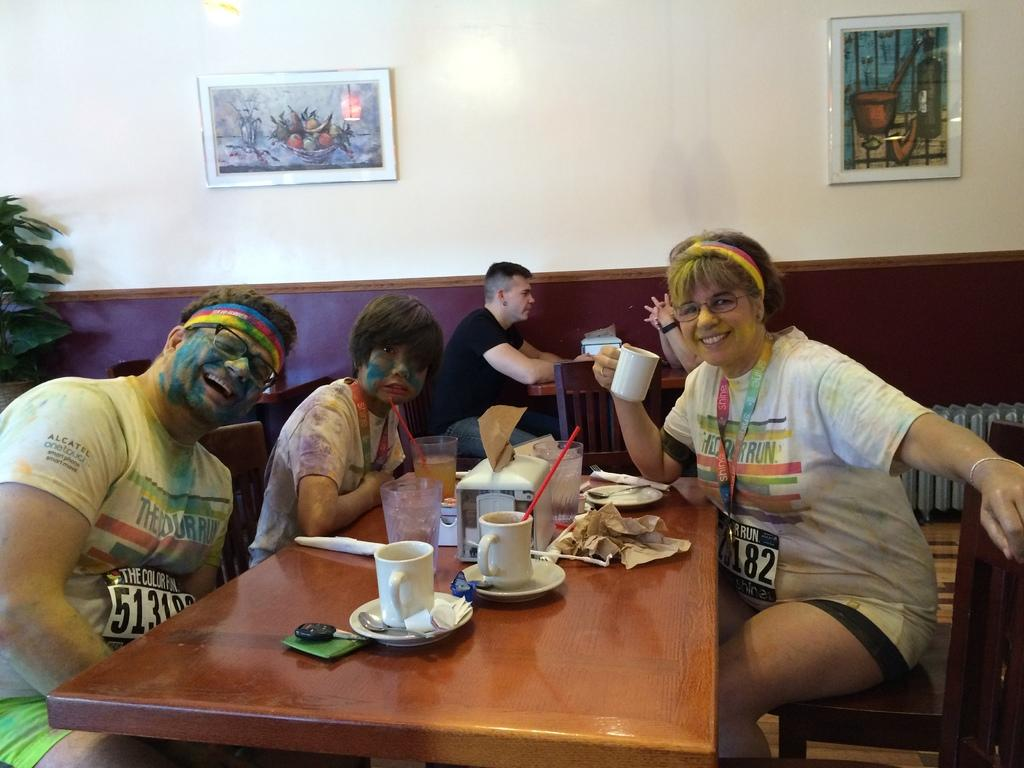How many people are sitting in the image? There are five people sitting on chairs in the image. What objects can be seen on the table? There is a cup, a saucer, a spoon, a straw, and a glass on the table. What is attached to the wall in the image? Frames are attached to the wall. What type of shoes are the people wearing in the image? There is no information about shoes in the image, as the focus is on the people sitting on chairs and the objects on the table. 